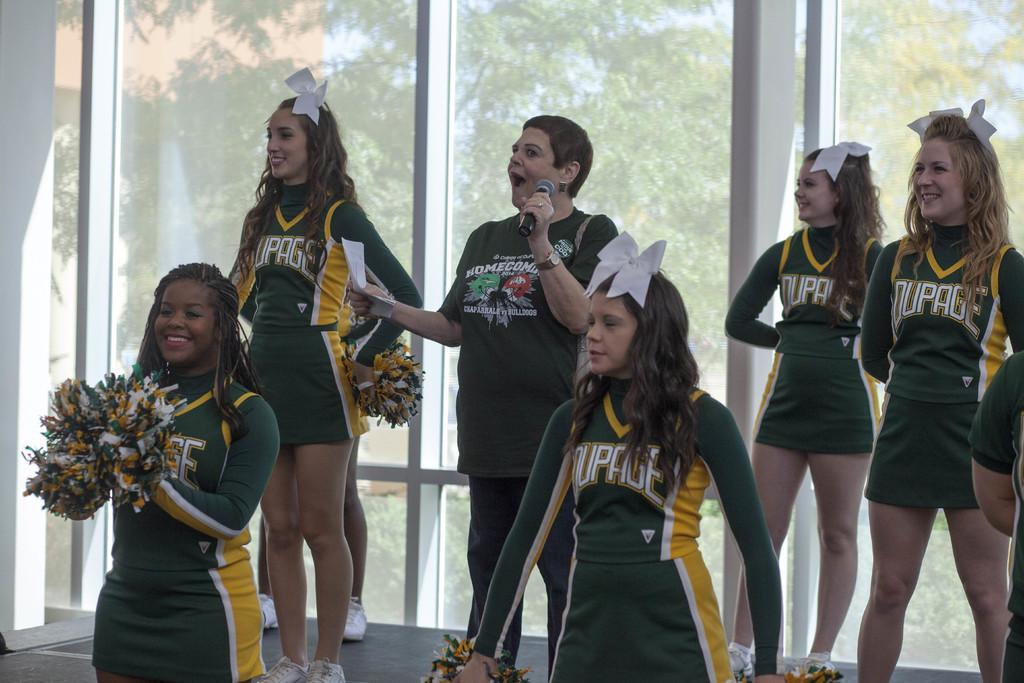Provide a one-sentence caption for the provided image. A bunch of cheerleaders with a slogan that ends in the word e on their chest. 